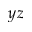<formula> <loc_0><loc_0><loc_500><loc_500>y z</formula> 